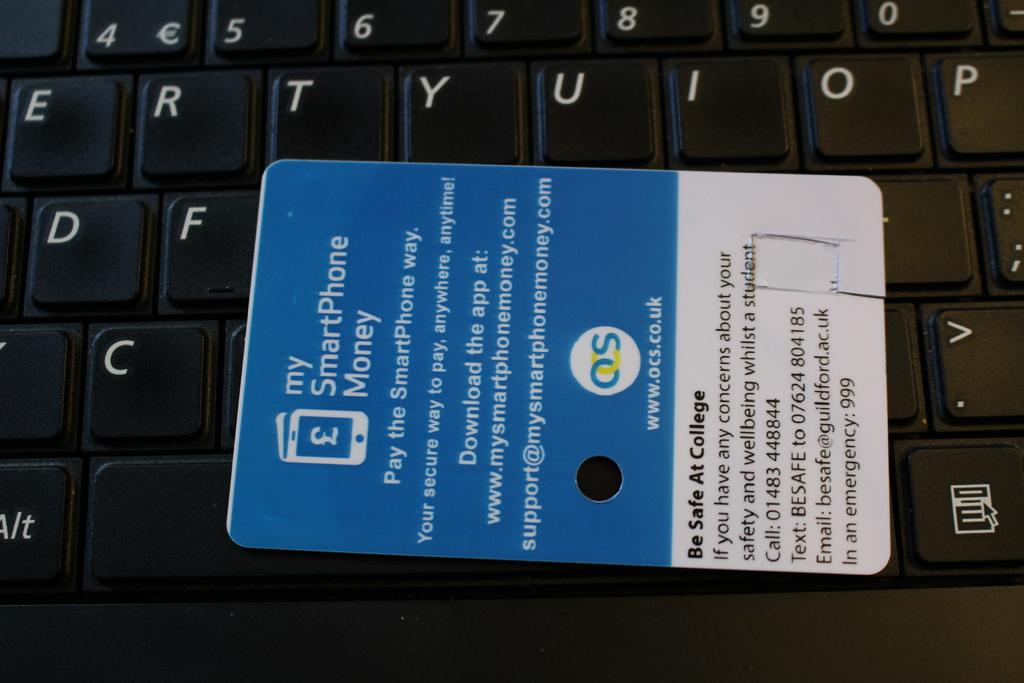<image>
Summarize the visual content of the image. An OCS logo is on a blue and white advertisement for an app. 